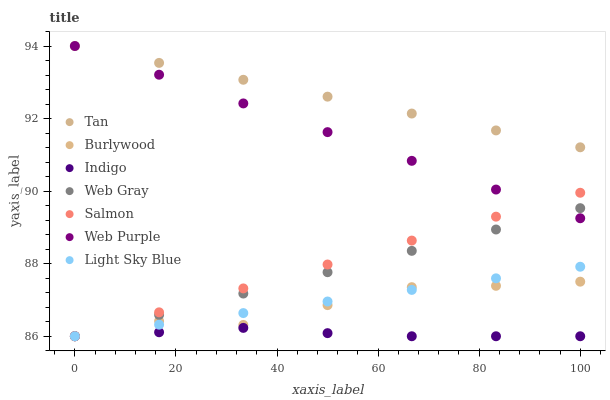Does Indigo have the minimum area under the curve?
Answer yes or no. Yes. Does Tan have the maximum area under the curve?
Answer yes or no. Yes. Does Burlywood have the minimum area under the curve?
Answer yes or no. No. Does Burlywood have the maximum area under the curve?
Answer yes or no. No. Is Web Purple the smoothest?
Answer yes or no. Yes. Is Burlywood the roughest?
Answer yes or no. Yes. Is Indigo the smoothest?
Answer yes or no. No. Is Indigo the roughest?
Answer yes or no. No. Does Web Gray have the lowest value?
Answer yes or no. Yes. Does Web Purple have the lowest value?
Answer yes or no. No. Does Tan have the highest value?
Answer yes or no. Yes. Does Burlywood have the highest value?
Answer yes or no. No. Is Burlywood less than Web Purple?
Answer yes or no. Yes. Is Web Purple greater than Burlywood?
Answer yes or no. Yes. Does Web Purple intersect Salmon?
Answer yes or no. Yes. Is Web Purple less than Salmon?
Answer yes or no. No. Is Web Purple greater than Salmon?
Answer yes or no. No. Does Burlywood intersect Web Purple?
Answer yes or no. No. 